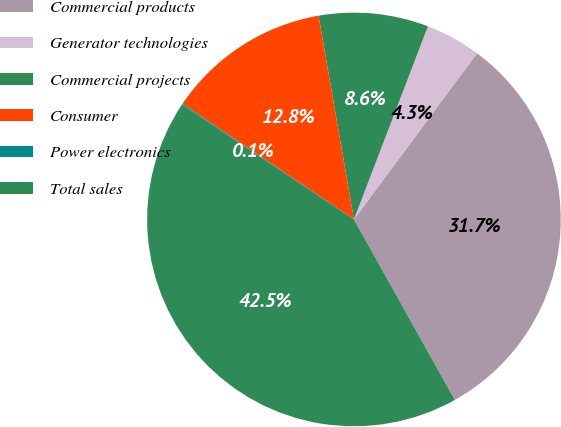Convert chart to OTSL. <chart><loc_0><loc_0><loc_500><loc_500><pie_chart><fcel>Commercial products<fcel>Generator technologies<fcel>Commercial projects<fcel>Consumer<fcel>Power electronics<fcel>Total sales<nl><fcel>31.74%<fcel>4.32%<fcel>8.56%<fcel>12.8%<fcel>0.08%<fcel>42.48%<nl></chart> 